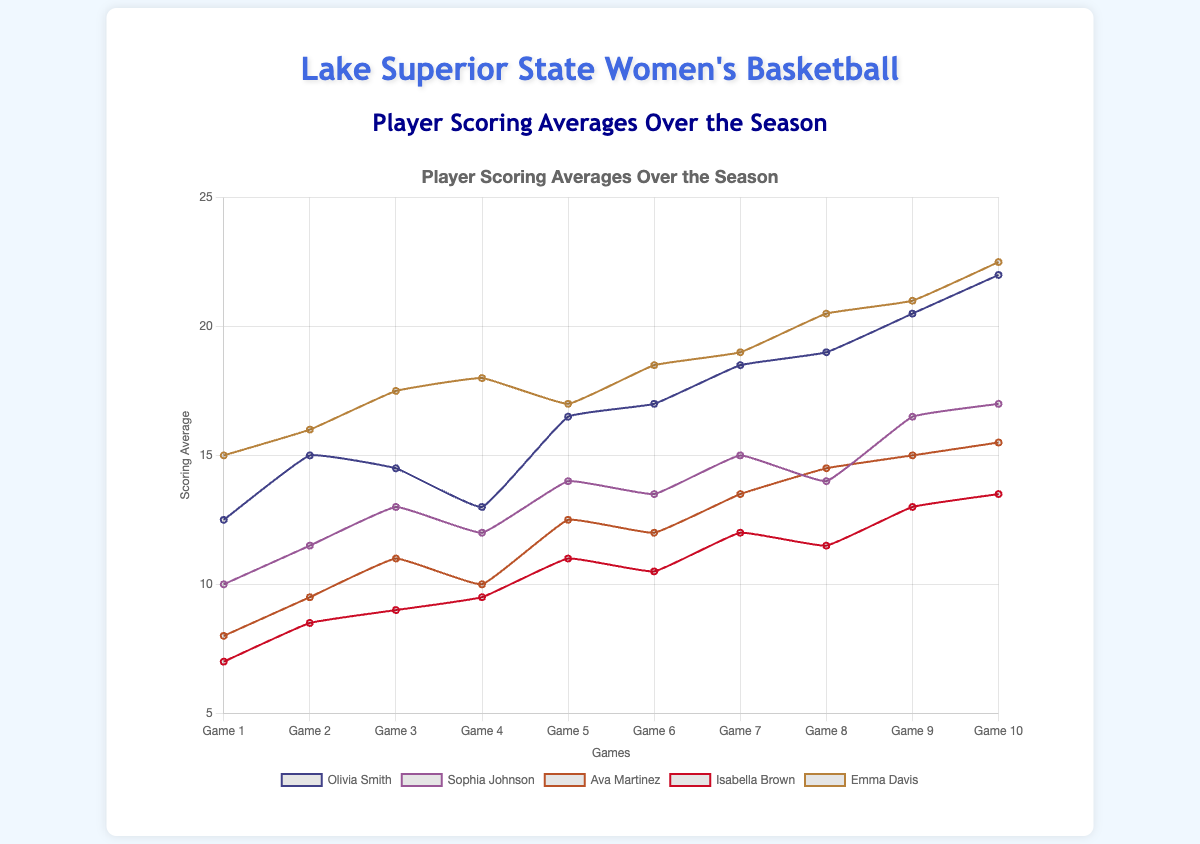What trend can be observed in Olivia Smith's scoring average over the season? Olivia Smith's scoring average generally increases over the season, starting from 12.5 in Game 1 and reaching 22.0 by Game 10. There is a slight dip in Game 4, but the overall trend is upward.
Answer: Rising trend with a dip in Game 4 Who had the highest scoring average in Game 5? By comparing the scoring averages for Game 5, Emma Davis has the highest average with 17.0 points.
Answer: Emma Davis Which player showed the most steady improvement in their scoring average? By examining the progression lines for all players, Ava Martinez shows a gradual and consistent rise in scoring average from Game 1 (8.0) to Game 10 (15.5) without significant dips.
Answer: Ava Martinez Between Olivia Smith and Emma Davis, whose scoring average was higher in the middle of the season (Game 5)? Comparing their scores in Game 5, Olivia Smith has a scoring average of 16.5, while Emma Davis has 17.0. So, Emma Davis had a higher average.
Answer: Emma Davis What is the difference in scoring averages between Sophia Johnson and Isabella Brown in Game 7? Sophia Johnson's average in Game 7 is 15.0, and Isabella Brown's is 12.0. The difference is 15.0 - 12.0, which equals 3.0.
Answer: 3.0 Which player had the lowest scoring average in Game 1? By comparing the scores of all players in Game 1, Isabella Brown had the lowest average of 7.0 points.
Answer: Isabella Brown How many players scored an average of more than 20 points in Game 10? According to the scoring averages, three players—Olivia Smith (22.0), Emma Davis (22.5), and no other players—scored more than 20 points in Game 10.
Answer: Two players What is the combined scoring average of Ava Martinez and Sophia Johnson in Game 8? Ava Martinez scored 14.5, and Sophia Johnson scored 14.0 in Game 8. Adding them gives 14.5 + 14.0 = 28.5.
Answer: 28.5 Who had the largest increase in their scoring average from Game 1 to Game 10? Comparing the differences between their averages from Game 1 to Game 10: 
Olivia Smith (22.0 - 12.5 = 9.5), 
Emma Davis (22.5 - 15.0 = 7.5), 
Sophia Johnson (17.0 - 10.0 = 7.0), 
Ava Martinez (15.5 - 8.0 = 7.5), 
Isabella Brown (13.5 - 7.0 = 6.5). 
Olivia Smith had the largest increase.
Answer: Olivia Smith In which game did Sophia Johnson have the same scoring average as another player? In Game 8, Sophia Johnson (14.0) and Ava Martinez (14.5) had different averages, but the closest match is Game 6 where both Sophia Johnson and Olivia Smith have very close averages (13.5). No exact same match.
Answer: No exact match 